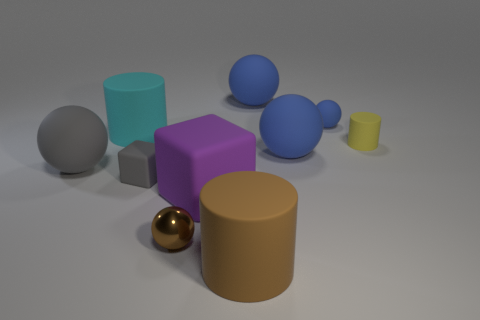Subtract all gray cubes. How many blue balls are left? 3 Subtract all brown balls. How many balls are left? 4 Subtract all brown spheres. How many spheres are left? 4 Subtract 2 balls. How many balls are left? 3 Subtract all brown balls. Subtract all gray cubes. How many balls are left? 4 Subtract all cylinders. How many objects are left? 7 Subtract all cyan cylinders. Subtract all big matte things. How many objects are left? 3 Add 4 tiny yellow matte objects. How many tiny yellow matte objects are left? 5 Add 4 metal objects. How many metal objects exist? 5 Subtract 3 blue spheres. How many objects are left? 7 